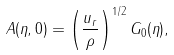<formula> <loc_0><loc_0><loc_500><loc_500>A ( \eta , 0 ) = \left ( \frac { u _ { r } } { \rho } \right ) ^ { 1 / 2 } G _ { 0 } ( \eta ) ,</formula> 